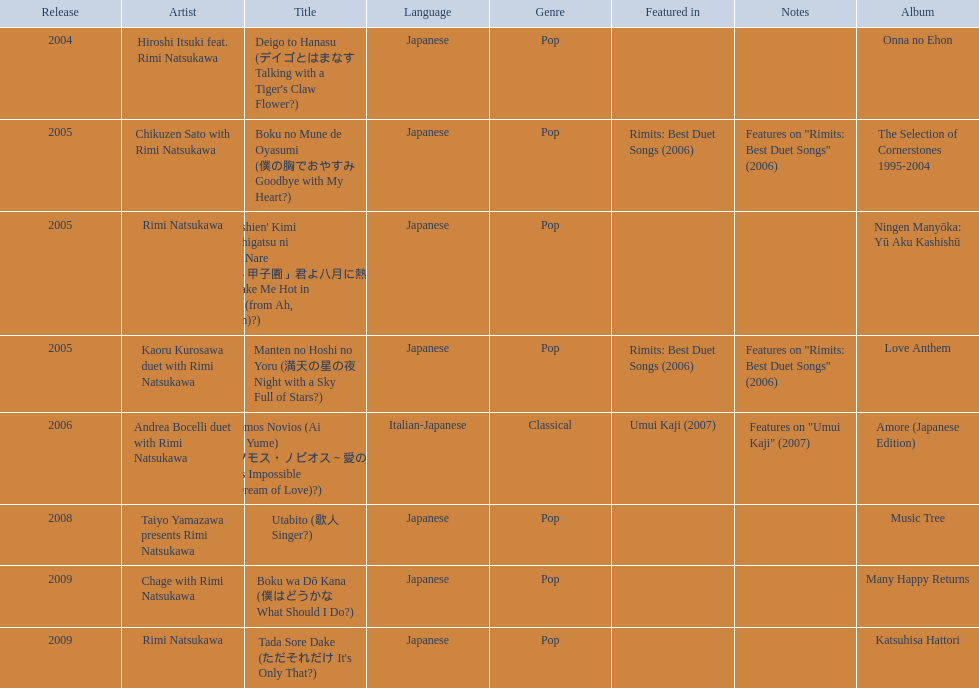Which title of the rimi natsukawa discography was released in the 2004? Deigo to Hanasu (デイゴとはまなす Talking with a Tiger's Claw Flower?). Which title has notes that features on/rimits. best duet songs\2006 Manten no Hoshi no Yoru (満天の星の夜 Night with a Sky Full of Stars?). Which title share the same notes as night with a sky full of stars? Boku no Mune de Oyasumi (僕の胸でおやすみ Goodbye with My Heart?). 